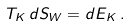<formula> <loc_0><loc_0><loc_500><loc_500>T _ { K } \, d S _ { W } = d E _ { K } \, .</formula> 